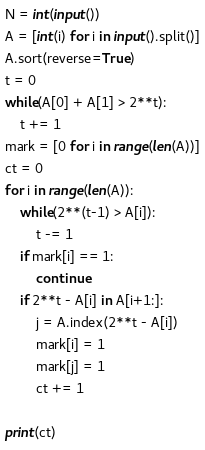<code> <loc_0><loc_0><loc_500><loc_500><_Python_>N = int(input())
A = [int(i) for i in input().split()]
A.sort(reverse=True)
t = 0
while(A[0] + A[1] > 2**t):
    t += 1
mark = [0 for i in range(len(A))]
ct = 0
for i in range(len(A)):
    while(2**(t-1) > A[i]):
        t -= 1
    if mark[i] == 1:
        continue
    if 2**t - A[i] in A[i+1:]:
        j = A.index(2**t - A[i])
        mark[i] = 1
        mark[j] = 1
        ct += 1

print(ct)
</code> 